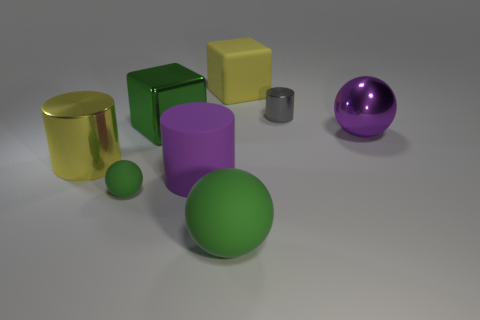Is there a gray thing that has the same material as the purple sphere?
Keep it short and to the point. Yes. What is the green object behind the large cylinder that is to the right of the large yellow metal cylinder made of?
Ensure brevity in your answer.  Metal. What number of other tiny gray shiny things are the same shape as the small gray object?
Your response must be concise. 0. The big yellow matte thing has what shape?
Make the answer very short. Cube. Is the number of big brown rubber things less than the number of shiny objects?
Your answer should be very brief. Yes. Is there anything else that has the same size as the yellow cube?
Offer a very short reply. Yes. What is the material of the big purple object that is the same shape as the gray metallic thing?
Provide a short and direct response. Rubber. Is the number of tiny cylinders greater than the number of big cyan cylinders?
Your answer should be very brief. Yes. How many other objects are the same color as the small rubber thing?
Offer a terse response. 2. Do the purple cylinder and the large green object that is in front of the small green rubber ball have the same material?
Keep it short and to the point. Yes. 